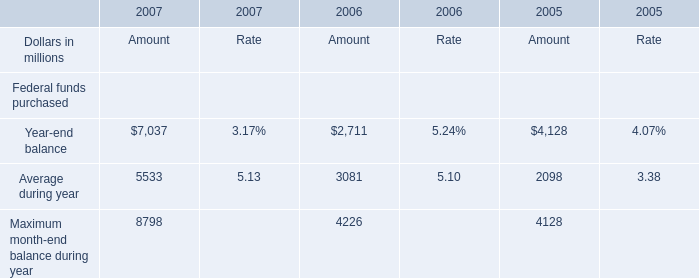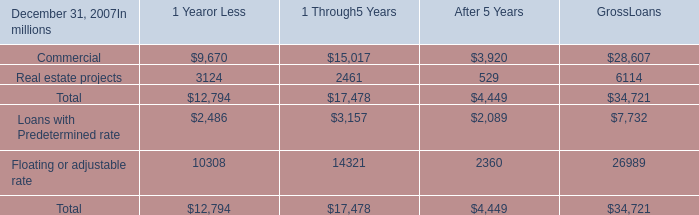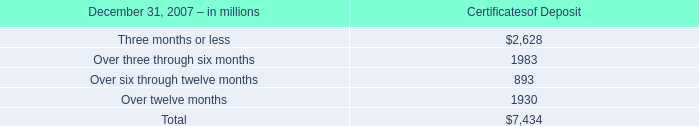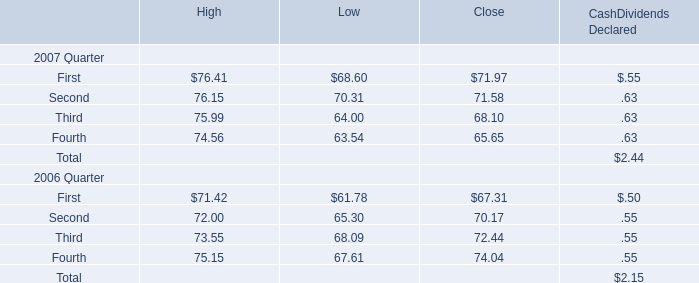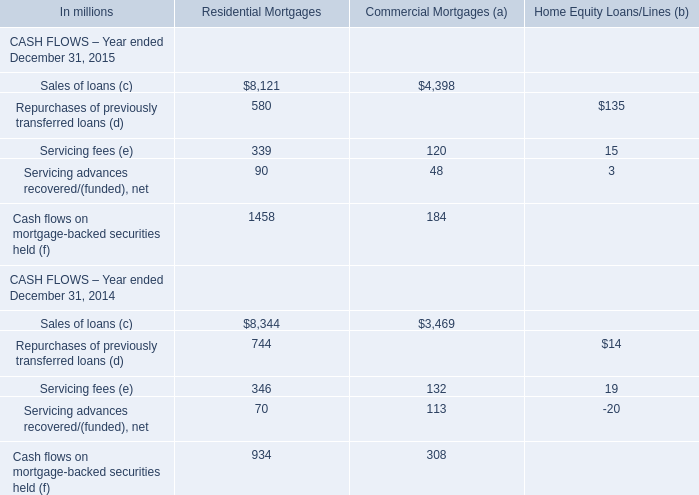Which year is the Amount for Average during year the highest? 
Answer: 2007. 